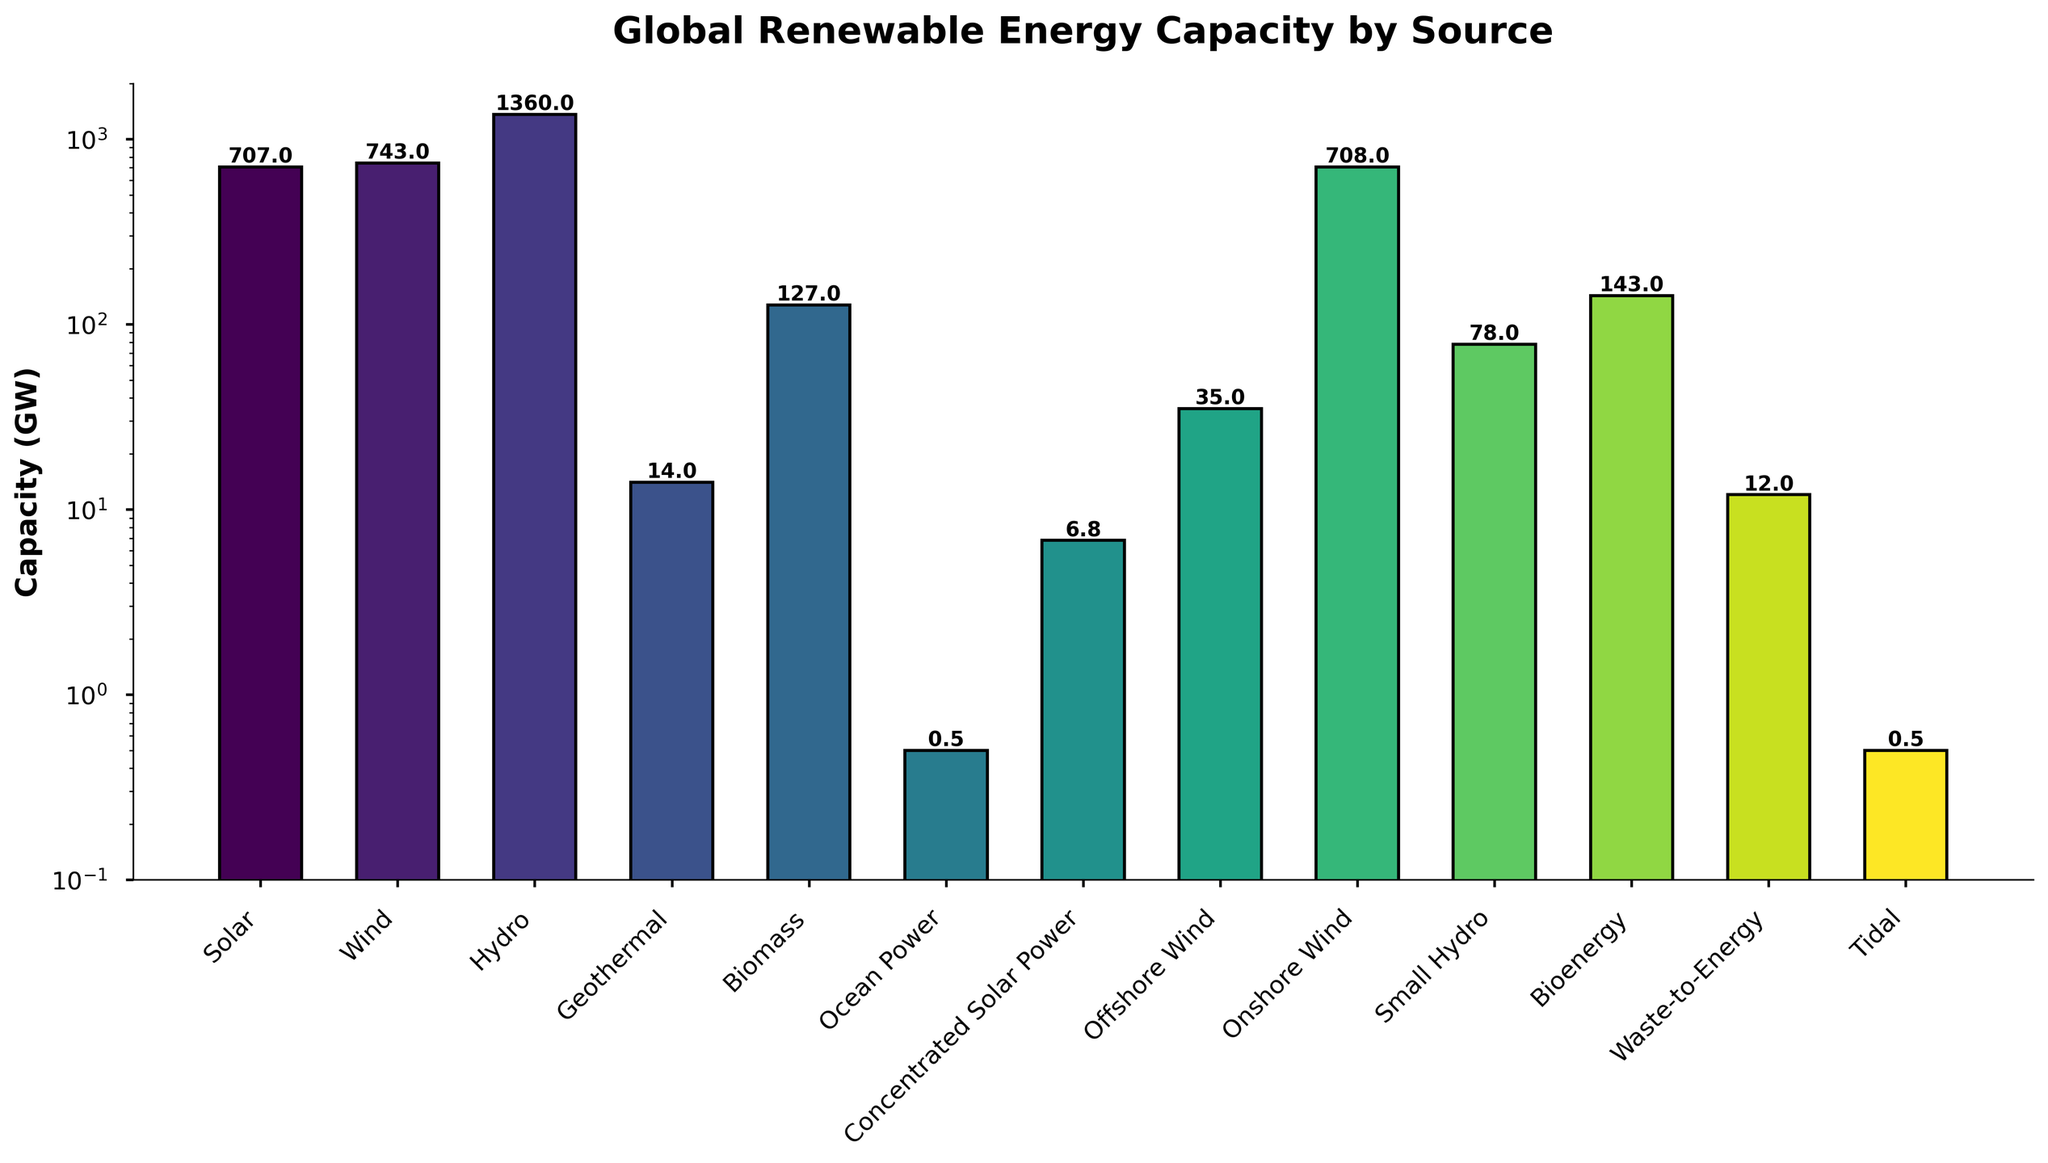Which renewable energy source has the highest capacity? The plot shows the different renewable energy sources and their capacities in gigawatts (GW). The source with the tallest bar represents the highest capacity.
Answer: Hydro Which renewable energy source has the lowest capacity? By observing the bars, the shortest one represents the source with the lowest capacity.
Answer: Ocean Power and Tidal What is the total capacity of all wind energy sources combined? Sum the capacities of Offshore Wind (35 GW) and Onshore Wind (708 GW): 35 + 708 = 743 GW.
Answer: 743 GW What’s the difference in capacity between the highest and the second highest sources? The highest capacity is Hydro (1360 GW) and the second highest is Wind (743 GW). Subtract the Wind capacity from the Hydro capacity: 1360 - 743 = 617 GW.
Answer: 617 GW Among Solar, Wind, and Biomass, which one has the highest capacity? Compare the heights of the bars for Solar (707 GW), Wind (743 GW), and Biomass (127 GW). Wind has the highest capacity.
Answer: Wind What’s the average capacity of Geothermal, Biomass, and Waste-to-Energy? Average the capacities of Geothermal (14 GW), Biomass (127 GW), and Waste-to-Energy (12 GW): (14 + 127 + 12) / 3 ≈ 51 GW.
Answer: 51 GW How much greater is the capacity of Hydro compared to Solar? Subtract the Solar capacity (707 GW) from the Hydro capacity (1360 GW): 1360 - 707 = 653 GW.
Answer: 653 GW Which is higher, the capacity of Onshore Wind or the combined capacity of Solar and Offshore Wind? Compare the capacity of Onshore Wind (708 GW) to the combined capacity of Solar (707 GW) and Offshore Wind (35 GW): 707 + 35 = 742 GW. Onshore Wind is lower.
Answer: Solar and Offshore Wind combined How many energy sources have a capacity greater than 100 GW? Identify the sources with capacities greater than 100 GW: Solar (707 GW), Wind (743 GW), Hydro (1360 GW), and Biomass (127 GW). So, there are four sources.
Answer: Four What is the combined capacity of all sources except Hydro? Sum the capacities of all sources excluding Hydro: Solar (707 GW), Wind (743 GW), Geothermal (14 GW), Biomass (127 GW), Ocean Power (0.5 GW), Concentrated Solar Power (6.8 GW), Offshore Wind (35 GW), Onshore Wind (708 GW), Small Hydro (78 GW), Bioenergy (143 GW), Waste-to-Energy (12 GW), Tidal (0.5 GW). Total = 707 + 743 + 14 + 127 + 0.5 + 6.8 + 35 + 708 + 78 + 143 + 12 + 0.5 = 2575.8 GW.
Answer: 2575.8 GW 